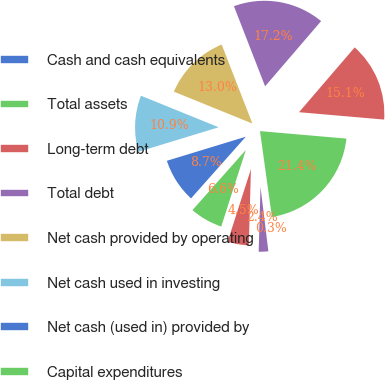Convert chart. <chart><loc_0><loc_0><loc_500><loc_500><pie_chart><fcel>Cash and cash equivalents<fcel>Total assets<fcel>Long-term debt<fcel>Total debt<fcel>Net cash provided by operating<fcel>Net cash used in investing<fcel>Net cash (used in) provided by<fcel>Capital expenditures<fcel>Purchases of treasury stock<fcel>Dividends paid<nl><fcel>0.26%<fcel>21.43%<fcel>15.08%<fcel>17.2%<fcel>12.96%<fcel>10.85%<fcel>8.73%<fcel>6.61%<fcel>4.5%<fcel>2.38%<nl></chart> 